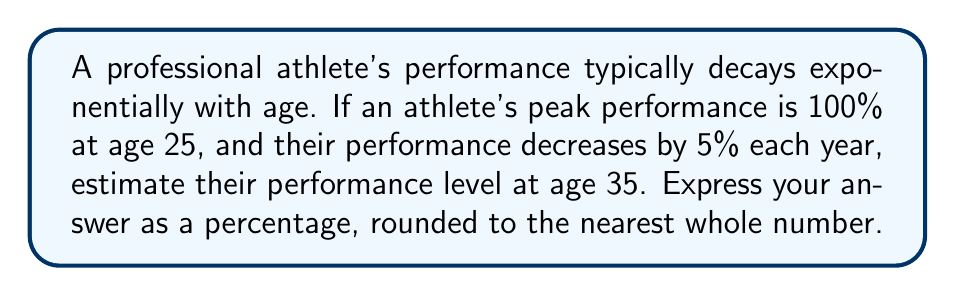Can you answer this question? Let's approach this step-by-step:

1) The decay rate is 5% per year, which means the athlete retains 95% of their performance each year.

2) We can express this as a decay factor of 0.95 (1 - 0.05 = 0.95).

3) The time period is 10 years (from age 25 to 35).

4) We can use the exponential decay formula:

   $$ P(t) = P_0 \cdot (1-r)^t $$

   Where:
   $P(t)$ is the performance after time $t$
   $P_0$ is the initial performance (100% in this case)
   $r$ is the decay rate (0.05 or 5%)
   $t$ is the time period (10 years)

5) Plugging in our values:

   $$ P(10) = 100 \cdot (0.95)^{10} $$

6) Calculate:

   $$ P(10) = 100 \cdot 0.5987 = 59.87\% $$

7) Rounding to the nearest whole number:

   $$ P(10) \approx 60\% $$

Therefore, the athlete's estimated performance at age 35 is approximately 60% of their peak performance.
Answer: 60% 